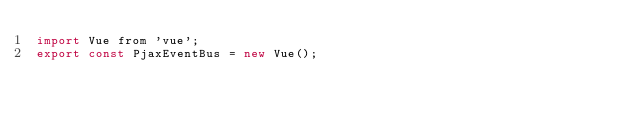Convert code to text. <code><loc_0><loc_0><loc_500><loc_500><_JavaScript_>import Vue from 'vue';
export const PjaxEventBus = new Vue();</code> 